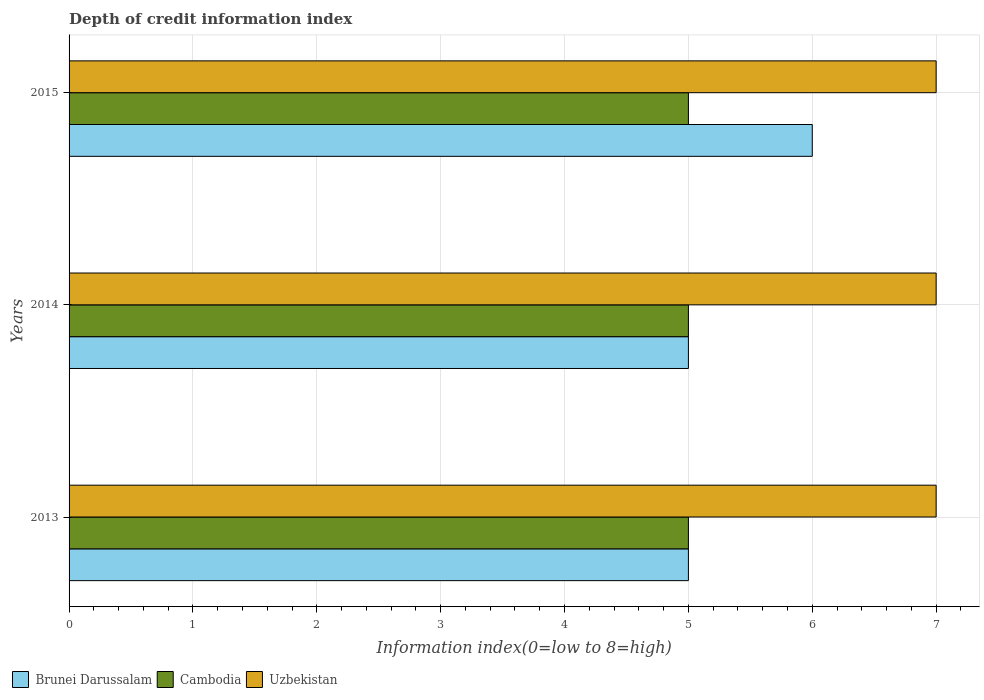How many groups of bars are there?
Keep it short and to the point. 3. Are the number of bars per tick equal to the number of legend labels?
Offer a terse response. Yes. How many bars are there on the 3rd tick from the bottom?
Ensure brevity in your answer.  3. What is the information index in Cambodia in 2013?
Ensure brevity in your answer.  5. Across all years, what is the maximum information index in Brunei Darussalam?
Give a very brief answer. 6. Across all years, what is the minimum information index in Uzbekistan?
Offer a terse response. 7. In which year was the information index in Cambodia maximum?
Keep it short and to the point. 2013. What is the total information index in Brunei Darussalam in the graph?
Provide a short and direct response. 16. What is the difference between the information index in Uzbekistan in 2014 and that in 2015?
Make the answer very short. 0. What is the difference between the information index in Cambodia in 2014 and the information index in Brunei Darussalam in 2015?
Offer a terse response. -1. What is the average information index in Brunei Darussalam per year?
Provide a short and direct response. 5.33. In the year 2013, what is the difference between the information index in Brunei Darussalam and information index in Uzbekistan?
Your answer should be compact. -2. Is the information index in Cambodia in 2014 less than that in 2015?
Your answer should be compact. No. Is the difference between the information index in Brunei Darussalam in 2013 and 2014 greater than the difference between the information index in Uzbekistan in 2013 and 2014?
Offer a very short reply. No. What is the difference between the highest and the second highest information index in Brunei Darussalam?
Offer a terse response. 1. What is the difference between the highest and the lowest information index in Cambodia?
Your answer should be compact. 0. What does the 1st bar from the top in 2014 represents?
Make the answer very short. Uzbekistan. What does the 2nd bar from the bottom in 2013 represents?
Your answer should be compact. Cambodia. Is it the case that in every year, the sum of the information index in Cambodia and information index in Uzbekistan is greater than the information index in Brunei Darussalam?
Provide a succinct answer. Yes. How many bars are there?
Ensure brevity in your answer.  9. How many years are there in the graph?
Offer a terse response. 3. What is the difference between two consecutive major ticks on the X-axis?
Your response must be concise. 1. Are the values on the major ticks of X-axis written in scientific E-notation?
Make the answer very short. No. How are the legend labels stacked?
Keep it short and to the point. Horizontal. What is the title of the graph?
Keep it short and to the point. Depth of credit information index. What is the label or title of the X-axis?
Offer a terse response. Information index(0=low to 8=high). What is the label or title of the Y-axis?
Provide a short and direct response. Years. What is the Information index(0=low to 8=high) in Brunei Darussalam in 2013?
Provide a short and direct response. 5. What is the Information index(0=low to 8=high) in Cambodia in 2013?
Offer a terse response. 5. What is the Information index(0=low to 8=high) in Brunei Darussalam in 2014?
Keep it short and to the point. 5. What is the Information index(0=low to 8=high) of Cambodia in 2015?
Keep it short and to the point. 5. Across all years, what is the maximum Information index(0=low to 8=high) of Cambodia?
Make the answer very short. 5. Across all years, what is the minimum Information index(0=low to 8=high) in Brunei Darussalam?
Provide a short and direct response. 5. Across all years, what is the minimum Information index(0=low to 8=high) in Cambodia?
Keep it short and to the point. 5. Across all years, what is the minimum Information index(0=low to 8=high) of Uzbekistan?
Make the answer very short. 7. What is the total Information index(0=low to 8=high) in Cambodia in the graph?
Your answer should be compact. 15. What is the difference between the Information index(0=low to 8=high) in Cambodia in 2013 and that in 2014?
Your answer should be very brief. 0. What is the difference between the Information index(0=low to 8=high) in Uzbekistan in 2013 and that in 2014?
Offer a very short reply. 0. What is the difference between the Information index(0=low to 8=high) of Uzbekistan in 2013 and that in 2015?
Offer a terse response. 0. What is the difference between the Information index(0=low to 8=high) of Brunei Darussalam in 2014 and that in 2015?
Keep it short and to the point. -1. What is the difference between the Information index(0=low to 8=high) of Uzbekistan in 2014 and that in 2015?
Offer a very short reply. 0. What is the difference between the Information index(0=low to 8=high) of Brunei Darussalam in 2013 and the Information index(0=low to 8=high) of Cambodia in 2014?
Give a very brief answer. 0. What is the difference between the Information index(0=low to 8=high) of Brunei Darussalam in 2013 and the Information index(0=low to 8=high) of Uzbekistan in 2014?
Provide a succinct answer. -2. What is the difference between the Information index(0=low to 8=high) in Brunei Darussalam in 2013 and the Information index(0=low to 8=high) in Cambodia in 2015?
Your answer should be very brief. 0. What is the difference between the Information index(0=low to 8=high) of Brunei Darussalam in 2013 and the Information index(0=low to 8=high) of Uzbekistan in 2015?
Offer a terse response. -2. What is the difference between the Information index(0=low to 8=high) in Cambodia in 2013 and the Information index(0=low to 8=high) in Uzbekistan in 2015?
Ensure brevity in your answer.  -2. What is the difference between the Information index(0=low to 8=high) in Brunei Darussalam in 2014 and the Information index(0=low to 8=high) in Cambodia in 2015?
Your response must be concise. 0. What is the average Information index(0=low to 8=high) in Brunei Darussalam per year?
Offer a terse response. 5.33. What is the average Information index(0=low to 8=high) of Cambodia per year?
Provide a short and direct response. 5. In the year 2013, what is the difference between the Information index(0=low to 8=high) of Brunei Darussalam and Information index(0=low to 8=high) of Cambodia?
Provide a short and direct response. 0. In the year 2013, what is the difference between the Information index(0=low to 8=high) of Brunei Darussalam and Information index(0=low to 8=high) of Uzbekistan?
Your answer should be very brief. -2. In the year 2014, what is the difference between the Information index(0=low to 8=high) in Brunei Darussalam and Information index(0=low to 8=high) in Cambodia?
Provide a succinct answer. 0. In the year 2014, what is the difference between the Information index(0=low to 8=high) of Brunei Darussalam and Information index(0=low to 8=high) of Uzbekistan?
Make the answer very short. -2. In the year 2015, what is the difference between the Information index(0=low to 8=high) in Cambodia and Information index(0=low to 8=high) in Uzbekistan?
Your answer should be very brief. -2. What is the ratio of the Information index(0=low to 8=high) of Brunei Darussalam in 2013 to that in 2014?
Give a very brief answer. 1. What is the ratio of the Information index(0=low to 8=high) in Cambodia in 2013 to that in 2014?
Provide a succinct answer. 1. What is the ratio of the Information index(0=low to 8=high) in Brunei Darussalam in 2013 to that in 2015?
Offer a very short reply. 0.83. What is the ratio of the Information index(0=low to 8=high) of Cambodia in 2013 to that in 2015?
Your answer should be very brief. 1. What is the ratio of the Information index(0=low to 8=high) of Uzbekistan in 2013 to that in 2015?
Offer a terse response. 1. What is the ratio of the Information index(0=low to 8=high) of Brunei Darussalam in 2014 to that in 2015?
Provide a succinct answer. 0.83. What is the difference between the highest and the second highest Information index(0=low to 8=high) of Brunei Darussalam?
Ensure brevity in your answer.  1. What is the difference between the highest and the second highest Information index(0=low to 8=high) in Cambodia?
Provide a succinct answer. 0. What is the difference between the highest and the second highest Information index(0=low to 8=high) in Uzbekistan?
Keep it short and to the point. 0. What is the difference between the highest and the lowest Information index(0=low to 8=high) of Cambodia?
Provide a succinct answer. 0. What is the difference between the highest and the lowest Information index(0=low to 8=high) in Uzbekistan?
Offer a terse response. 0. 